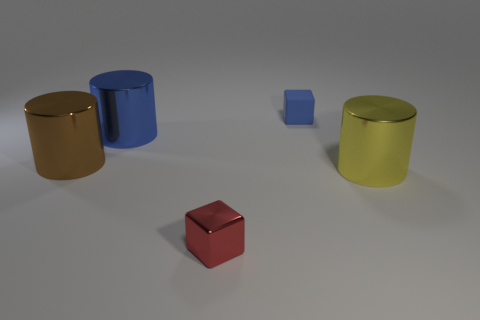Subtract all blue cylinders. How many cylinders are left? 2 Add 4 yellow shiny cylinders. How many objects exist? 9 Subtract all brown cylinders. How many cylinders are left? 2 Subtract all cylinders. How many objects are left? 2 Subtract 2 blocks. How many blocks are left? 0 Subtract all gray cylinders. Subtract all cyan cubes. How many cylinders are left? 3 Subtract all brown spheres. How many blue cubes are left? 1 Subtract all yellow metal cylinders. Subtract all metallic objects. How many objects are left? 0 Add 2 blue matte things. How many blue matte things are left? 3 Add 5 yellow metal things. How many yellow metal things exist? 6 